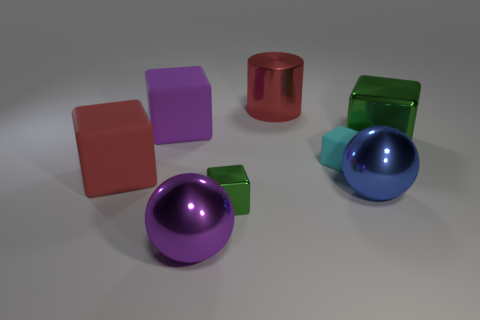How many objects are balls or green metal cubes that are right of the metal cylinder? 3 